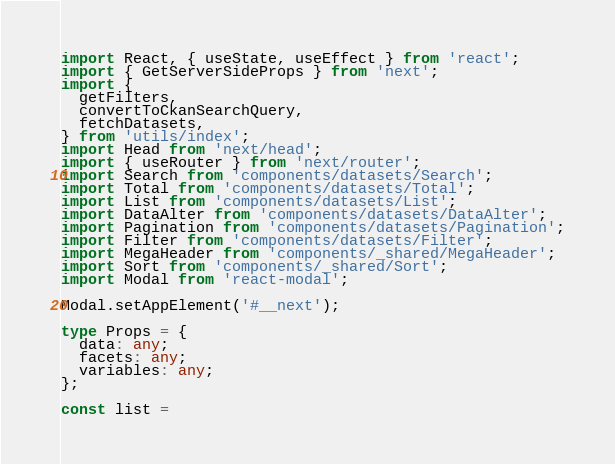Convert code to text. <code><loc_0><loc_0><loc_500><loc_500><_TypeScript_>import React, { useState, useEffect } from 'react';
import { GetServerSideProps } from 'next';
import {
  getFilters,
  convertToCkanSearchQuery,
  fetchDatasets,
} from 'utils/index';
import Head from 'next/head';
import { useRouter } from 'next/router';
import Search from 'components/datasets/Search';
import Total from 'components/datasets/Total';
import List from 'components/datasets/List';
import DataAlter from 'components/datasets/DataAlter';
import Pagination from 'components/datasets/Pagination';
import Filter from 'components/datasets/Filter';
import MegaHeader from 'components/_shared/MegaHeader';
import Sort from 'components/_shared/Sort';
import Modal from 'react-modal';

Modal.setAppElement('#__next');

type Props = {
  data: any;
  facets: any;
  variables: any;
};

const list =</code> 